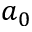Convert formula to latex. <formula><loc_0><loc_0><loc_500><loc_500>a _ { 0 }</formula> 